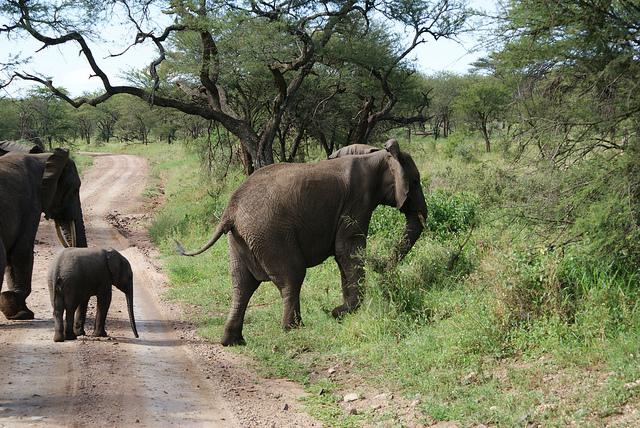How many elephants are standing right on the dirt road to the left? Please explain your reasoning. two. The third one is in the grass. 